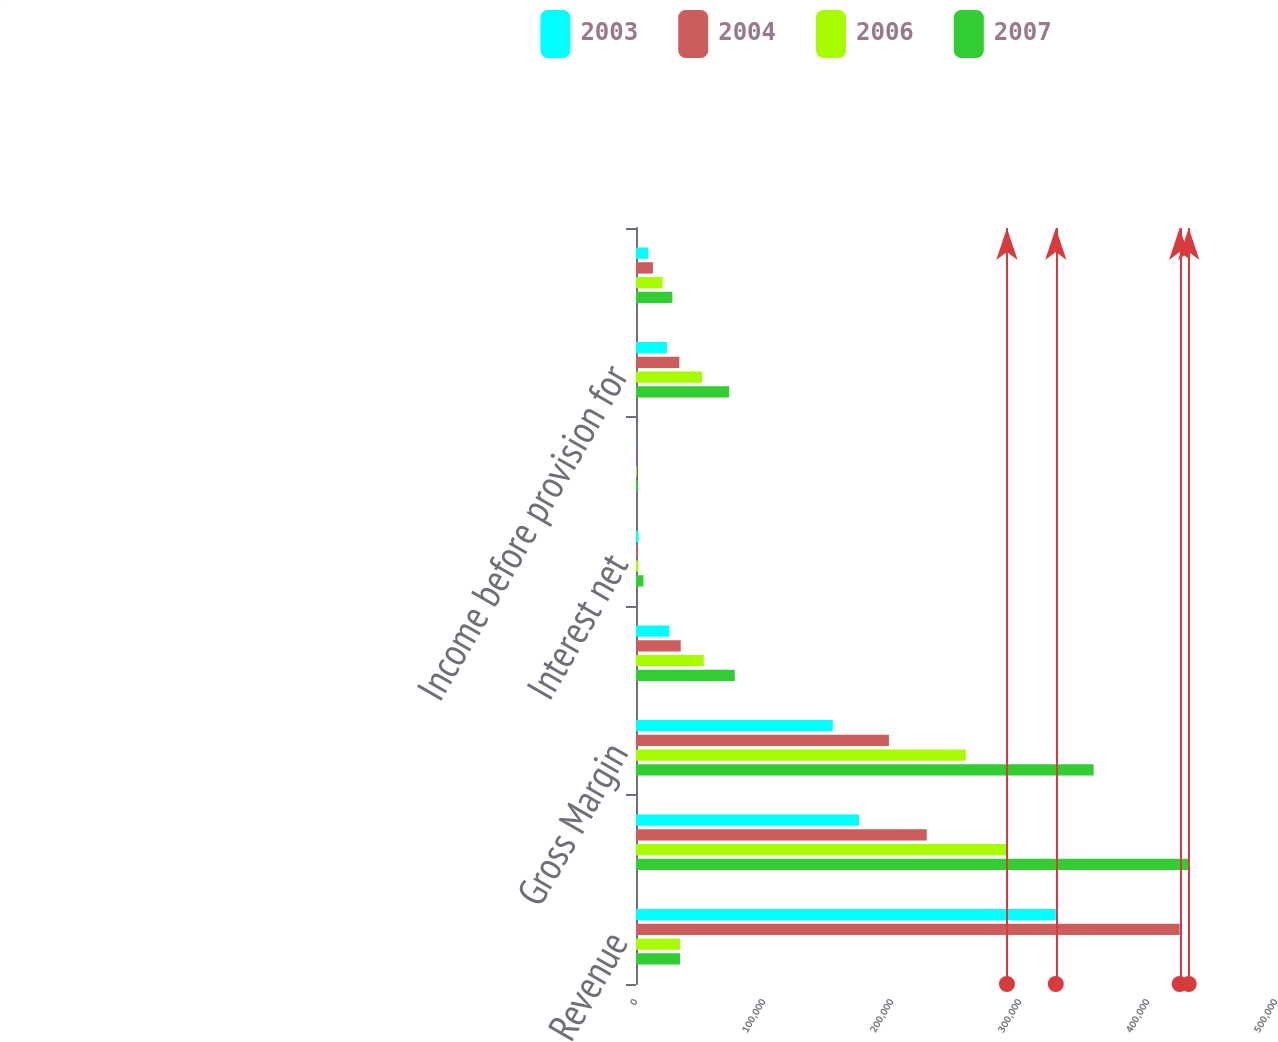<chart> <loc_0><loc_0><loc_500><loc_500><stacked_bar_chart><ecel><fcel>Revenue<fcel>Cost of goods sold<fcel>Gross Margin<fcel>Operating income<fcel>Interest net<fcel>Other net<fcel>Income before provision for<fcel>Provision for income taxes<nl><fcel>2003<fcel>327974<fcel>174238<fcel>153736<fcel>26059<fcel>2023<fcel>117<fcel>24153<fcel>9577<nl><fcel>2004<fcel>424756<fcel>227140<fcel>197616<fcel>34907<fcel>1505<fcel>455<fcel>33857<fcel>13284<nl><fcel>2006<fcel>34382<fcel>289788<fcel>257604<fcel>52942<fcel>1887<fcel>628<fcel>51683<fcel>20796<nl><fcel>2007<fcel>34382<fcel>431832<fcel>357549<fcel>77166<fcel>5824<fcel>1479<fcel>72821<fcel>28426<nl></chart> 